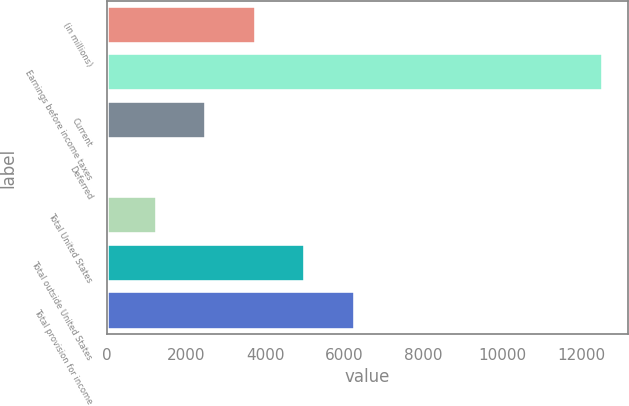Convert chart. <chart><loc_0><loc_0><loc_500><loc_500><bar_chart><fcel>(in millions)<fcel>Earnings before income taxes<fcel>Current<fcel>Deferred<fcel>Total United States<fcel>Total outside United States<fcel>Total provision for income<nl><fcel>3766.1<fcel>12542<fcel>2512.4<fcel>5<fcel>1258.7<fcel>5019.8<fcel>6273.5<nl></chart> 